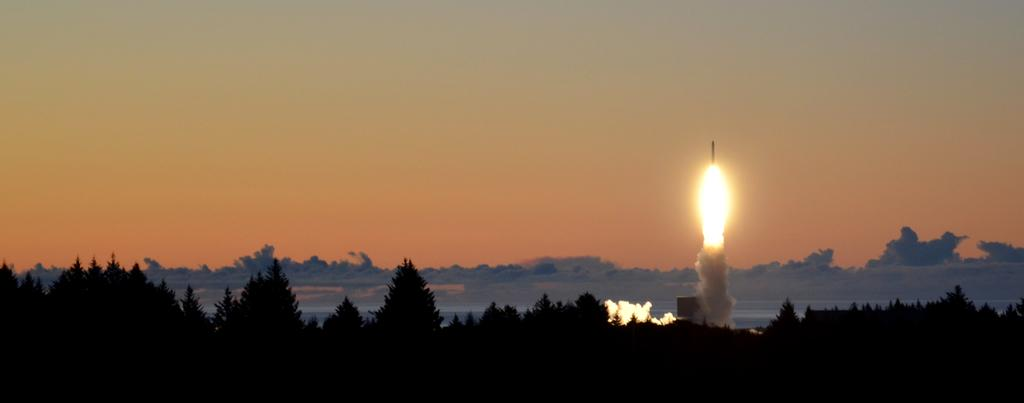What type of vegetation can be seen in the image? There are trees in the image. What else is visible in the image besides the trees? There is smoke visible in the image, as well as a rocket in the air. What is visible at the top of the image? The sky is visible at the top of the image. How many eggs can be seen on the rocket in the image? There are no eggs present in the image; the rocket is the only visible object in the air. Can you describe the ghost that is hiding behind the trees in the image? There is no ghost present in the image; only trees, smoke, a rocket, and the sky are visible. 